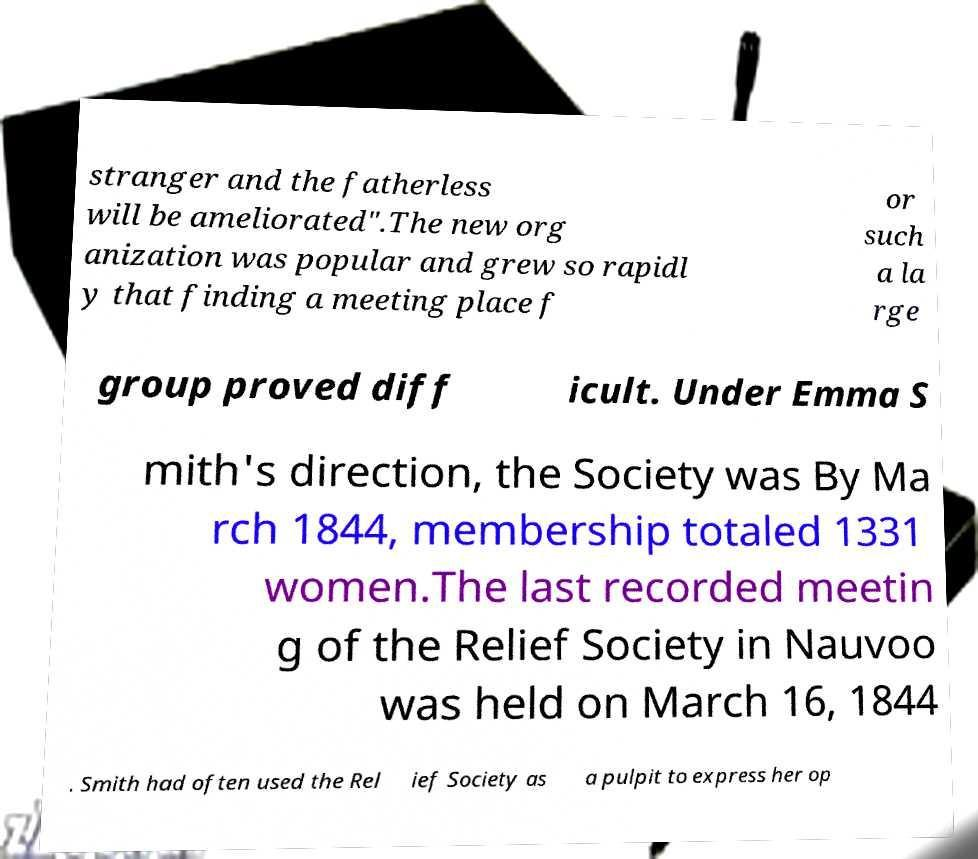Can you accurately transcribe the text from the provided image for me? stranger and the fatherless will be ameliorated".The new org anization was popular and grew so rapidl y that finding a meeting place f or such a la rge group proved diff icult. Under Emma S mith's direction, the Society was By Ma rch 1844, membership totaled 1331 women.The last recorded meetin g of the Relief Society in Nauvoo was held on March 16, 1844 . Smith had often used the Rel ief Society as a pulpit to express her op 